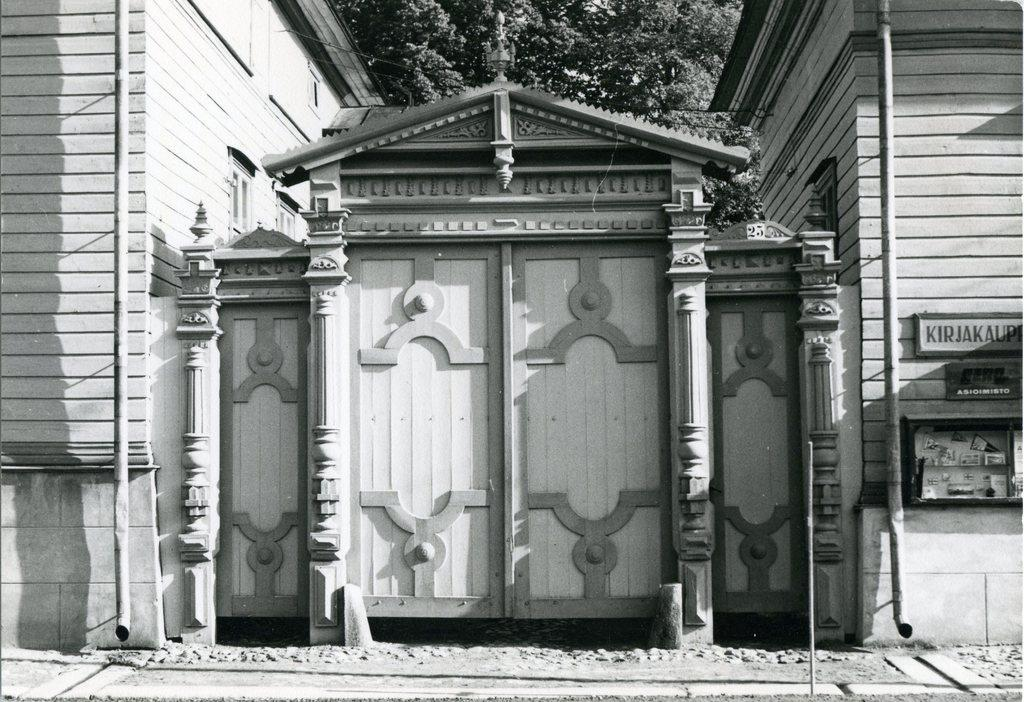What type of gate is visible in the image? There is a wooden gate in the image. What structures are located near the gate? There are buildings on either side of the gate. What can be seen in the background of the image? There are trees in the background of the image. What word is written on the tooth in the image? There is no tooth or word present in the image. What type of advertisement can be seen on the gate in the image? There is no advertisement present on the gate in the image. 